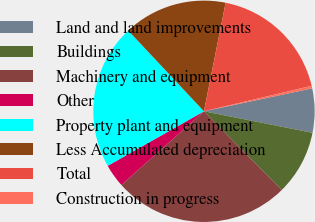Convert chart. <chart><loc_0><loc_0><loc_500><loc_500><pie_chart><fcel>Land and land improvements<fcel>Buildings<fcel>Machinery and equipment<fcel>Other<fcel>Property plant and equipment<fcel>Less Accumulated depreciation<fcel>Total<fcel>Construction in progress<nl><fcel>6.44%<fcel>9.48%<fcel>25.8%<fcel>3.4%<fcel>21.21%<fcel>15.13%<fcel>18.17%<fcel>0.37%<nl></chart> 